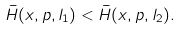<formula> <loc_0><loc_0><loc_500><loc_500>\bar { H } ( x , p , l _ { 1 } ) < \bar { H } ( x , p , l _ { 2 } ) .</formula> 